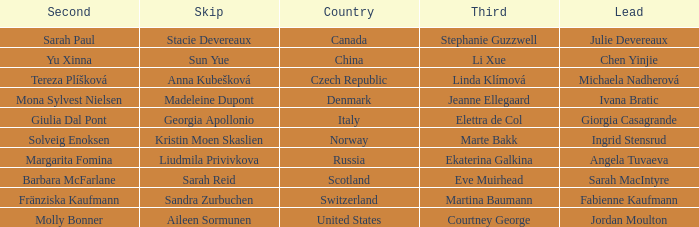What skip has norway as the country? Kristin Moen Skaslien. 